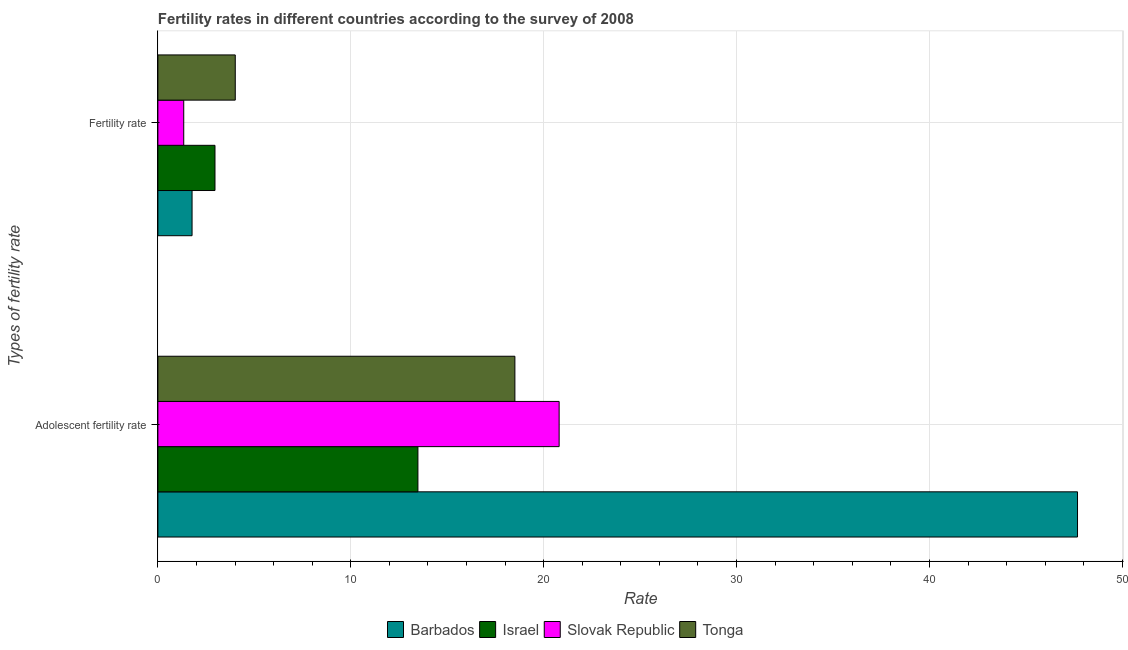Are the number of bars on each tick of the Y-axis equal?
Ensure brevity in your answer.  Yes. How many bars are there on the 2nd tick from the bottom?
Offer a very short reply. 4. What is the label of the 2nd group of bars from the top?
Your answer should be very brief. Adolescent fertility rate. What is the adolescent fertility rate in Barbados?
Your response must be concise. 47.68. Across all countries, what is the maximum fertility rate?
Provide a short and direct response. 4.01. Across all countries, what is the minimum fertility rate?
Provide a short and direct response. 1.34. In which country was the fertility rate maximum?
Offer a very short reply. Tonga. What is the total fertility rate in the graph?
Your answer should be very brief. 10.08. What is the difference between the fertility rate in Slovak Republic and that in Israel?
Provide a short and direct response. -1.62. What is the difference between the fertility rate in Israel and the adolescent fertility rate in Tonga?
Your response must be concise. -15.55. What is the average fertility rate per country?
Keep it short and to the point. 2.52. What is the difference between the fertility rate and adolescent fertility rate in Tonga?
Ensure brevity in your answer.  -14.5. In how many countries, is the adolescent fertility rate greater than 14 ?
Keep it short and to the point. 3. What is the ratio of the adolescent fertility rate in Israel to that in Barbados?
Keep it short and to the point. 0.28. What does the 1st bar from the top in Adolescent fertility rate represents?
Your response must be concise. Tonga. What does the 3rd bar from the bottom in Adolescent fertility rate represents?
Give a very brief answer. Slovak Republic. Are all the bars in the graph horizontal?
Your response must be concise. Yes. How many countries are there in the graph?
Make the answer very short. 4. Are the values on the major ticks of X-axis written in scientific E-notation?
Your answer should be very brief. No. Where does the legend appear in the graph?
Provide a succinct answer. Bottom center. How many legend labels are there?
Offer a very short reply. 4. How are the legend labels stacked?
Your response must be concise. Horizontal. What is the title of the graph?
Make the answer very short. Fertility rates in different countries according to the survey of 2008. Does "Cabo Verde" appear as one of the legend labels in the graph?
Keep it short and to the point. No. What is the label or title of the X-axis?
Make the answer very short. Rate. What is the label or title of the Y-axis?
Ensure brevity in your answer.  Types of fertility rate. What is the Rate of Barbados in Adolescent fertility rate?
Provide a succinct answer. 47.68. What is the Rate in Israel in Adolescent fertility rate?
Offer a terse response. 13.48. What is the Rate in Slovak Republic in Adolescent fertility rate?
Your answer should be very brief. 20.8. What is the Rate in Tonga in Adolescent fertility rate?
Make the answer very short. 18.51. What is the Rate in Barbados in Fertility rate?
Your response must be concise. 1.77. What is the Rate of Israel in Fertility rate?
Your response must be concise. 2.96. What is the Rate in Slovak Republic in Fertility rate?
Offer a very short reply. 1.34. What is the Rate of Tonga in Fertility rate?
Offer a terse response. 4.01. Across all Types of fertility rate, what is the maximum Rate in Barbados?
Offer a very short reply. 47.68. Across all Types of fertility rate, what is the maximum Rate of Israel?
Your answer should be very brief. 13.48. Across all Types of fertility rate, what is the maximum Rate of Slovak Republic?
Provide a succinct answer. 20.8. Across all Types of fertility rate, what is the maximum Rate in Tonga?
Your response must be concise. 18.51. Across all Types of fertility rate, what is the minimum Rate in Barbados?
Your answer should be compact. 1.77. Across all Types of fertility rate, what is the minimum Rate of Israel?
Keep it short and to the point. 2.96. Across all Types of fertility rate, what is the minimum Rate of Slovak Republic?
Provide a short and direct response. 1.34. Across all Types of fertility rate, what is the minimum Rate of Tonga?
Your response must be concise. 4.01. What is the total Rate of Barbados in the graph?
Provide a short and direct response. 49.45. What is the total Rate in Israel in the graph?
Ensure brevity in your answer.  16.44. What is the total Rate of Slovak Republic in the graph?
Your answer should be compact. 22.14. What is the total Rate of Tonga in the graph?
Your answer should be compact. 22.52. What is the difference between the Rate in Barbados in Adolescent fertility rate and that in Fertility rate?
Offer a very short reply. 45.91. What is the difference between the Rate in Israel in Adolescent fertility rate and that in Fertility rate?
Your response must be concise. 10.52. What is the difference between the Rate in Slovak Republic in Adolescent fertility rate and that in Fertility rate?
Offer a terse response. 19.46. What is the difference between the Rate of Tonga in Adolescent fertility rate and that in Fertility rate?
Give a very brief answer. 14.5. What is the difference between the Rate in Barbados in Adolescent fertility rate and the Rate in Israel in Fertility rate?
Offer a very short reply. 44.72. What is the difference between the Rate in Barbados in Adolescent fertility rate and the Rate in Slovak Republic in Fertility rate?
Offer a terse response. 46.34. What is the difference between the Rate of Barbados in Adolescent fertility rate and the Rate of Tonga in Fertility rate?
Your answer should be compact. 43.67. What is the difference between the Rate of Israel in Adolescent fertility rate and the Rate of Slovak Republic in Fertility rate?
Provide a succinct answer. 12.14. What is the difference between the Rate in Israel in Adolescent fertility rate and the Rate in Tonga in Fertility rate?
Ensure brevity in your answer.  9.47. What is the difference between the Rate of Slovak Republic in Adolescent fertility rate and the Rate of Tonga in Fertility rate?
Keep it short and to the point. 16.79. What is the average Rate in Barbados per Types of fertility rate?
Give a very brief answer. 24.72. What is the average Rate in Israel per Types of fertility rate?
Ensure brevity in your answer.  8.22. What is the average Rate of Slovak Republic per Types of fertility rate?
Make the answer very short. 11.07. What is the average Rate in Tonga per Types of fertility rate?
Give a very brief answer. 11.26. What is the difference between the Rate of Barbados and Rate of Israel in Adolescent fertility rate?
Offer a terse response. 34.2. What is the difference between the Rate in Barbados and Rate in Slovak Republic in Adolescent fertility rate?
Provide a short and direct response. 26.87. What is the difference between the Rate in Barbados and Rate in Tonga in Adolescent fertility rate?
Offer a terse response. 29.17. What is the difference between the Rate of Israel and Rate of Slovak Republic in Adolescent fertility rate?
Provide a short and direct response. -7.32. What is the difference between the Rate in Israel and Rate in Tonga in Adolescent fertility rate?
Give a very brief answer. -5.03. What is the difference between the Rate of Slovak Republic and Rate of Tonga in Adolescent fertility rate?
Keep it short and to the point. 2.29. What is the difference between the Rate of Barbados and Rate of Israel in Fertility rate?
Offer a terse response. -1.19. What is the difference between the Rate in Barbados and Rate in Slovak Republic in Fertility rate?
Your response must be concise. 0.43. What is the difference between the Rate of Barbados and Rate of Tonga in Fertility rate?
Provide a succinct answer. -2.24. What is the difference between the Rate of Israel and Rate of Slovak Republic in Fertility rate?
Keep it short and to the point. 1.62. What is the difference between the Rate of Israel and Rate of Tonga in Fertility rate?
Your answer should be very brief. -1.05. What is the difference between the Rate in Slovak Republic and Rate in Tonga in Fertility rate?
Your answer should be very brief. -2.67. What is the ratio of the Rate of Barbados in Adolescent fertility rate to that in Fertility rate?
Provide a succinct answer. 26.91. What is the ratio of the Rate of Israel in Adolescent fertility rate to that in Fertility rate?
Make the answer very short. 4.55. What is the ratio of the Rate of Slovak Republic in Adolescent fertility rate to that in Fertility rate?
Keep it short and to the point. 15.52. What is the ratio of the Rate of Tonga in Adolescent fertility rate to that in Fertility rate?
Your answer should be very brief. 4.61. What is the difference between the highest and the second highest Rate in Barbados?
Provide a succinct answer. 45.91. What is the difference between the highest and the second highest Rate in Israel?
Give a very brief answer. 10.52. What is the difference between the highest and the second highest Rate in Slovak Republic?
Make the answer very short. 19.46. What is the difference between the highest and the second highest Rate of Tonga?
Give a very brief answer. 14.5. What is the difference between the highest and the lowest Rate in Barbados?
Offer a very short reply. 45.91. What is the difference between the highest and the lowest Rate of Israel?
Give a very brief answer. 10.52. What is the difference between the highest and the lowest Rate of Slovak Republic?
Ensure brevity in your answer.  19.46. What is the difference between the highest and the lowest Rate in Tonga?
Make the answer very short. 14.5. 